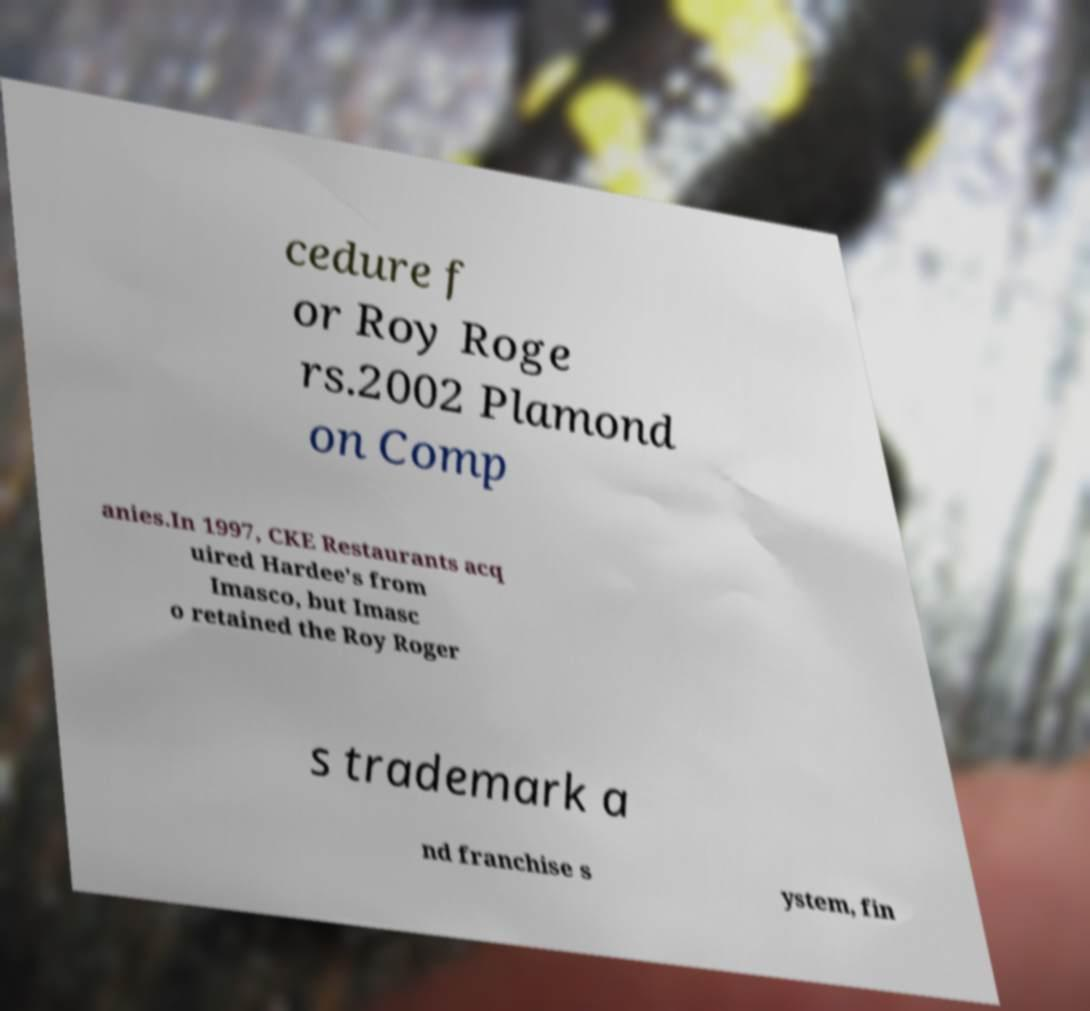Could you extract and type out the text from this image? cedure f or Roy Roge rs.2002 Plamond on Comp anies.In 1997, CKE Restaurants acq uired Hardee's from Imasco, but Imasc o retained the Roy Roger s trademark a nd franchise s ystem, fin 